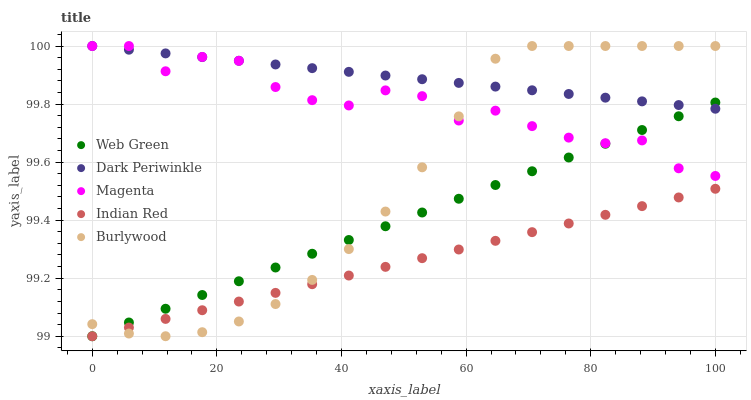Does Indian Red have the minimum area under the curve?
Answer yes or no. Yes. Does Dark Periwinkle have the maximum area under the curve?
Answer yes or no. Yes. Does Burlywood have the minimum area under the curve?
Answer yes or no. No. Does Burlywood have the maximum area under the curve?
Answer yes or no. No. Is Indian Red the smoothest?
Answer yes or no. Yes. Is Magenta the roughest?
Answer yes or no. Yes. Is Burlywood the smoothest?
Answer yes or no. No. Is Burlywood the roughest?
Answer yes or no. No. Does Indian Red have the lowest value?
Answer yes or no. Yes. Does Burlywood have the lowest value?
Answer yes or no. No. Does Dark Periwinkle have the highest value?
Answer yes or no. Yes. Does Web Green have the highest value?
Answer yes or no. No. Is Indian Red less than Dark Periwinkle?
Answer yes or no. Yes. Is Magenta greater than Indian Red?
Answer yes or no. Yes. Does Indian Red intersect Burlywood?
Answer yes or no. Yes. Is Indian Red less than Burlywood?
Answer yes or no. No. Is Indian Red greater than Burlywood?
Answer yes or no. No. Does Indian Red intersect Dark Periwinkle?
Answer yes or no. No. 